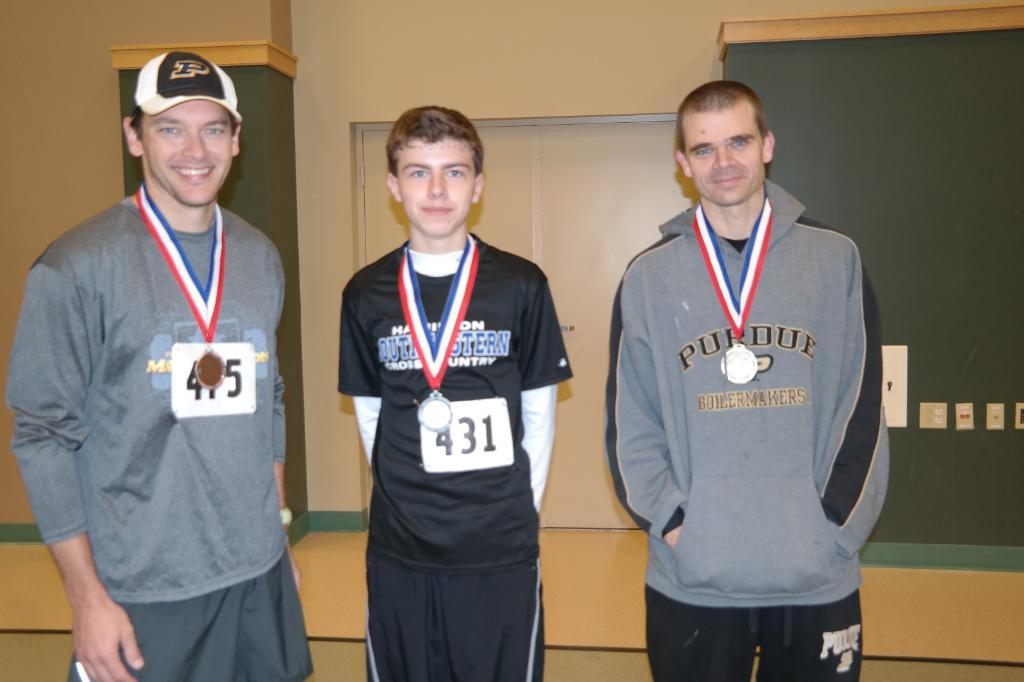<image>
Relay a brief, clear account of the picture shown. Men posing for a photo while wearing a sign that says 431. 